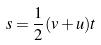<formula> <loc_0><loc_0><loc_500><loc_500>s = \frac { 1 } { 2 } ( v + u ) t</formula> 